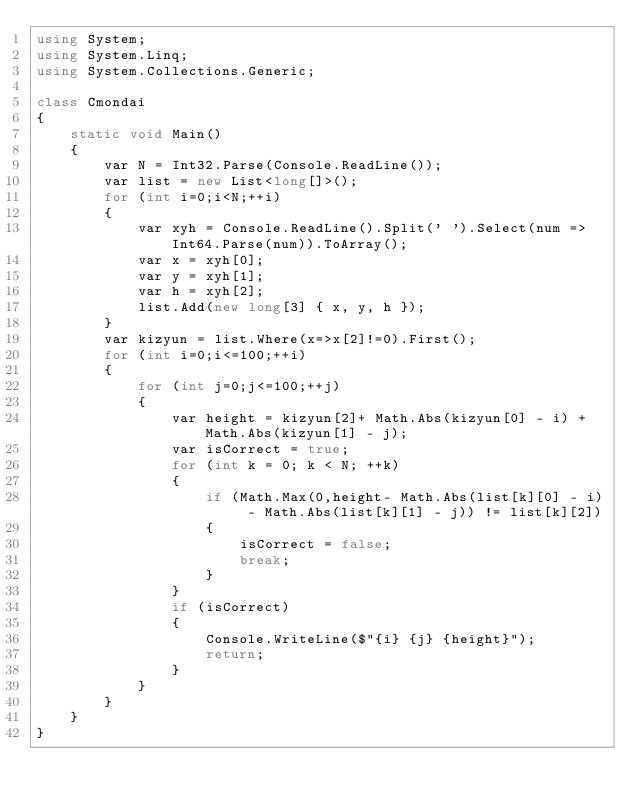Convert code to text. <code><loc_0><loc_0><loc_500><loc_500><_C#_>using System;
using System.Linq;
using System.Collections.Generic;

class Cmondai
{
    static void Main()
    {
        var N = Int32.Parse(Console.ReadLine());
        var list = new List<long[]>();
        for (int i=0;i<N;++i)
        {
            var xyh = Console.ReadLine().Split(' ').Select(num => Int64.Parse(num)).ToArray();
            var x = xyh[0];
            var y = xyh[1];
            var h = xyh[2];
            list.Add(new long[3] { x, y, h });
        }
        var kizyun = list.Where(x=>x[2]!=0).First();
        for (int i=0;i<=100;++i)
        {
            for (int j=0;j<=100;++j)
            {
                var height = kizyun[2]+ Math.Abs(kizyun[0] - i) + Math.Abs(kizyun[1] - j);
                var isCorrect = true;
                for (int k = 0; k < N; ++k)
                {
                    if (Math.Max(0,height- Math.Abs(list[k][0] - i) - Math.Abs(list[k][1] - j)) != list[k][2])
                    {
                        isCorrect = false;
                        break;
                    }
                }
                if (isCorrect)
                {
                    Console.WriteLine($"{i} {j} {height}");
                    return;
                }
            }
        }
    }
}</code> 